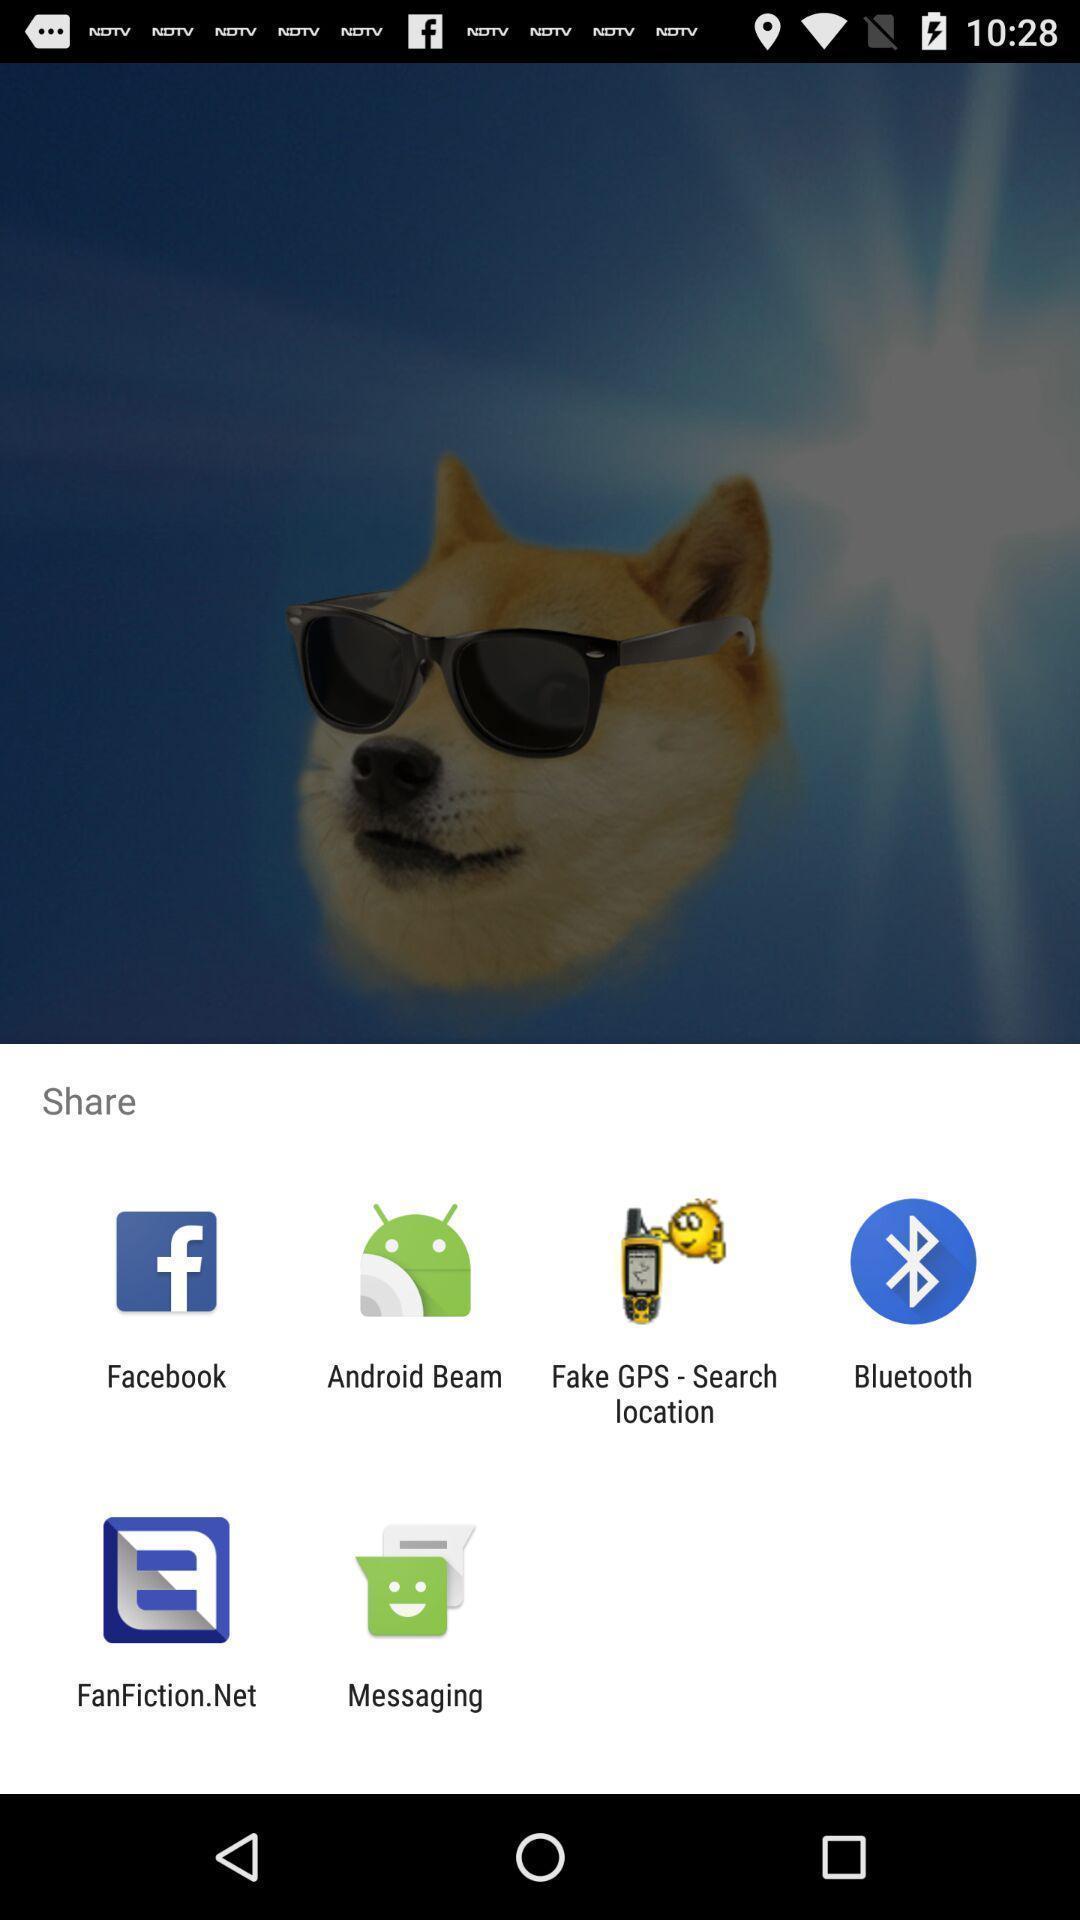What can you discern from this picture? Pop-up shows to share with multiple applications. 